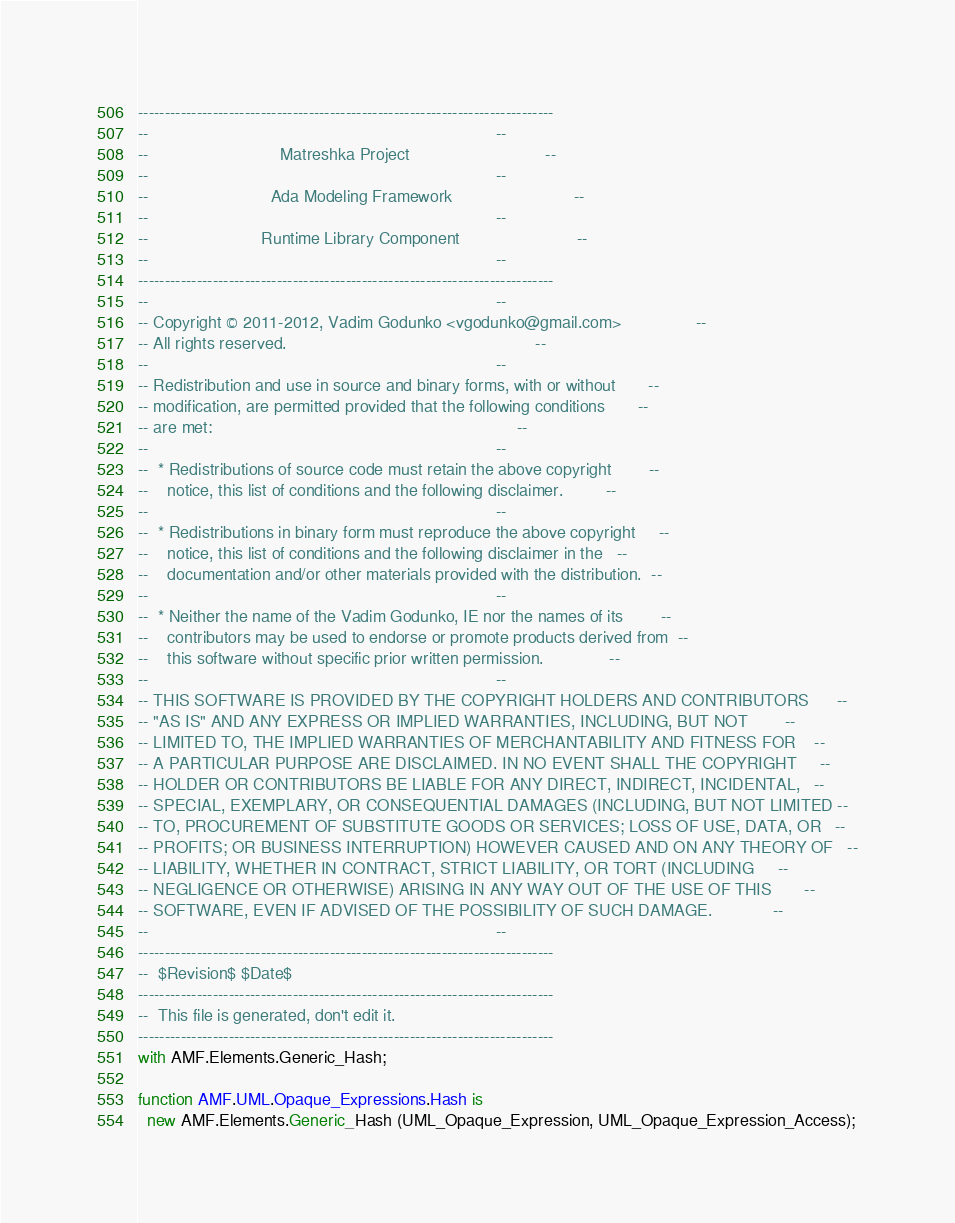<code> <loc_0><loc_0><loc_500><loc_500><_Ada_>------------------------------------------------------------------------------
--                                                                          --
--                            Matreshka Project                             --
--                                                                          --
--                          Ada Modeling Framework                          --
--                                                                          --
--                        Runtime Library Component                         --
--                                                                          --
------------------------------------------------------------------------------
--                                                                          --
-- Copyright © 2011-2012, Vadim Godunko <vgodunko@gmail.com>                --
-- All rights reserved.                                                     --
--                                                                          --
-- Redistribution and use in source and binary forms, with or without       --
-- modification, are permitted provided that the following conditions       --
-- are met:                                                                 --
--                                                                          --
--  * Redistributions of source code must retain the above copyright        --
--    notice, this list of conditions and the following disclaimer.         --
--                                                                          --
--  * Redistributions in binary form must reproduce the above copyright     --
--    notice, this list of conditions and the following disclaimer in the   --
--    documentation and/or other materials provided with the distribution.  --
--                                                                          --
--  * Neither the name of the Vadim Godunko, IE nor the names of its        --
--    contributors may be used to endorse or promote products derived from  --
--    this software without specific prior written permission.              --
--                                                                          --
-- THIS SOFTWARE IS PROVIDED BY THE COPYRIGHT HOLDERS AND CONTRIBUTORS      --
-- "AS IS" AND ANY EXPRESS OR IMPLIED WARRANTIES, INCLUDING, BUT NOT        --
-- LIMITED TO, THE IMPLIED WARRANTIES OF MERCHANTABILITY AND FITNESS FOR    --
-- A PARTICULAR PURPOSE ARE DISCLAIMED. IN NO EVENT SHALL THE COPYRIGHT     --
-- HOLDER OR CONTRIBUTORS BE LIABLE FOR ANY DIRECT, INDIRECT, INCIDENTAL,   --
-- SPECIAL, EXEMPLARY, OR CONSEQUENTIAL DAMAGES (INCLUDING, BUT NOT LIMITED --
-- TO, PROCUREMENT OF SUBSTITUTE GOODS OR SERVICES; LOSS OF USE, DATA, OR   --
-- PROFITS; OR BUSINESS INTERRUPTION) HOWEVER CAUSED AND ON ANY THEORY OF   --
-- LIABILITY, WHETHER IN CONTRACT, STRICT LIABILITY, OR TORT (INCLUDING     --
-- NEGLIGENCE OR OTHERWISE) ARISING IN ANY WAY OUT OF THE USE OF THIS       --
-- SOFTWARE, EVEN IF ADVISED OF THE POSSIBILITY OF SUCH DAMAGE.             --
--                                                                          --
------------------------------------------------------------------------------
--  $Revision$ $Date$
------------------------------------------------------------------------------
--  This file is generated, don't edit it.
------------------------------------------------------------------------------
with AMF.Elements.Generic_Hash;

function AMF.UML.Opaque_Expressions.Hash is
  new AMF.Elements.Generic_Hash (UML_Opaque_Expression, UML_Opaque_Expression_Access);
</code> 